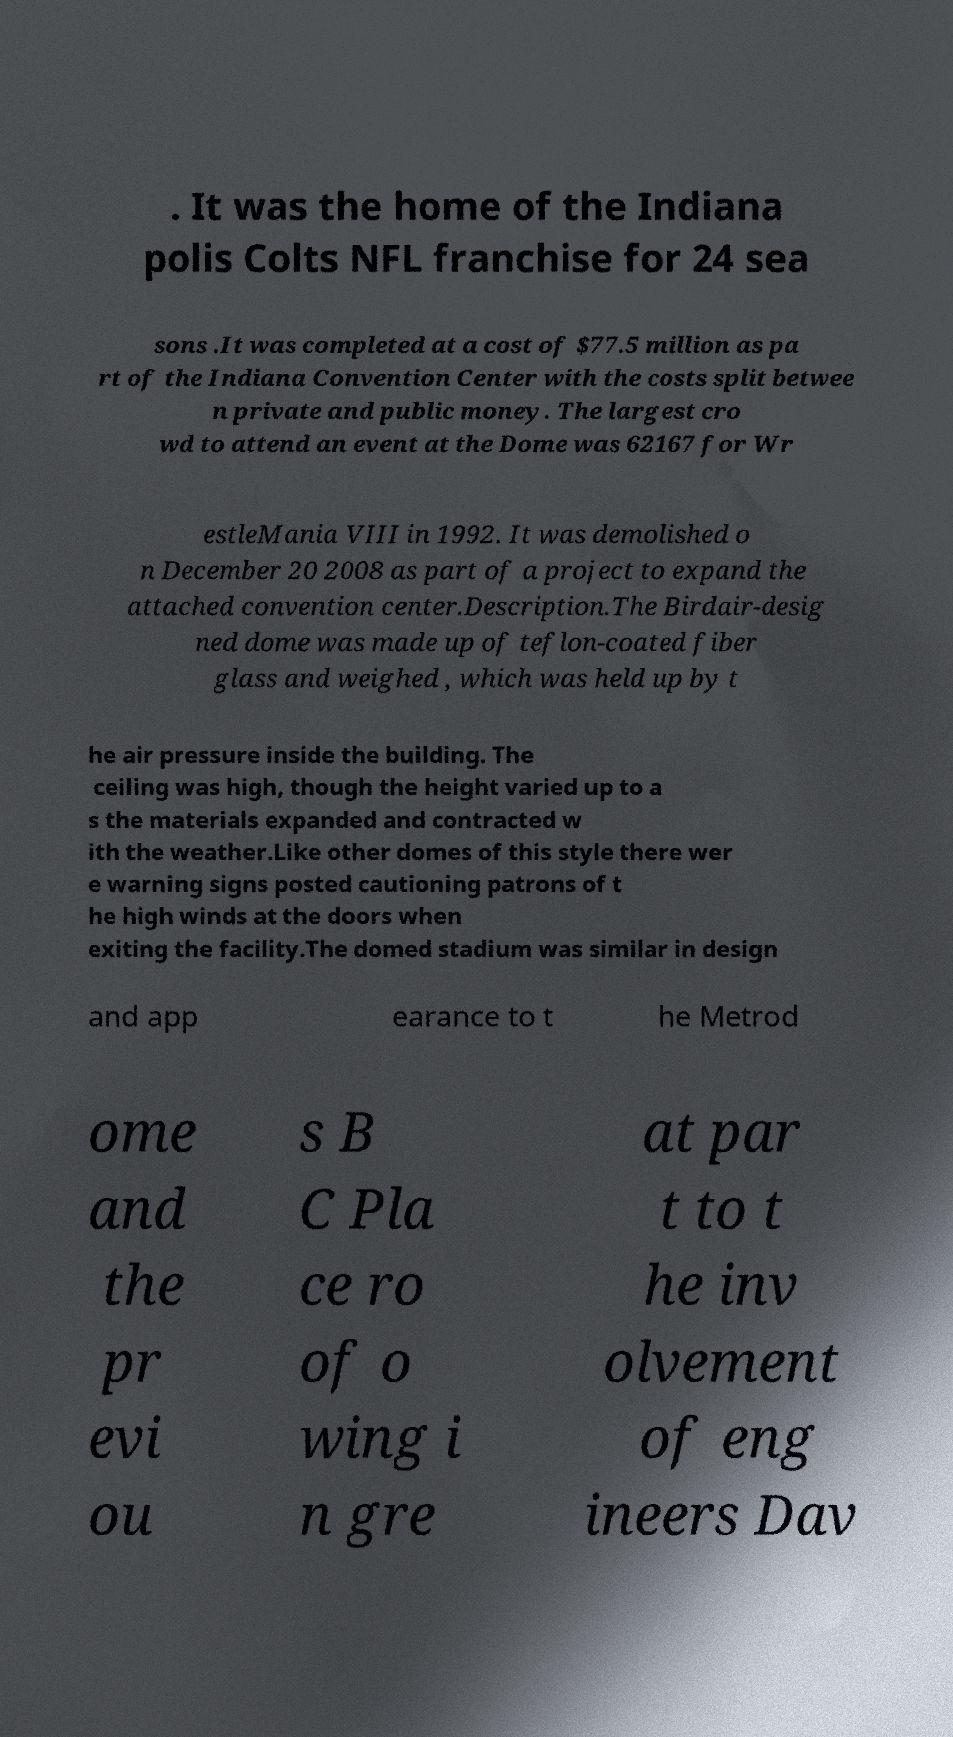Can you read and provide the text displayed in the image?This photo seems to have some interesting text. Can you extract and type it out for me? . It was the home of the Indiana polis Colts NFL franchise for 24 sea sons .It was completed at a cost of $77.5 million as pa rt of the Indiana Convention Center with the costs split betwee n private and public money. The largest cro wd to attend an event at the Dome was 62167 for Wr estleMania VIII in 1992. It was demolished o n December 20 2008 as part of a project to expand the attached convention center.Description.The Birdair-desig ned dome was made up of teflon-coated fiber glass and weighed , which was held up by t he air pressure inside the building. The ceiling was high, though the height varied up to a s the materials expanded and contracted w ith the weather.Like other domes of this style there wer e warning signs posted cautioning patrons of t he high winds at the doors when exiting the facility.The domed stadium was similar in design and app earance to t he Metrod ome and the pr evi ou s B C Pla ce ro of o wing i n gre at par t to t he inv olvement of eng ineers Dav 